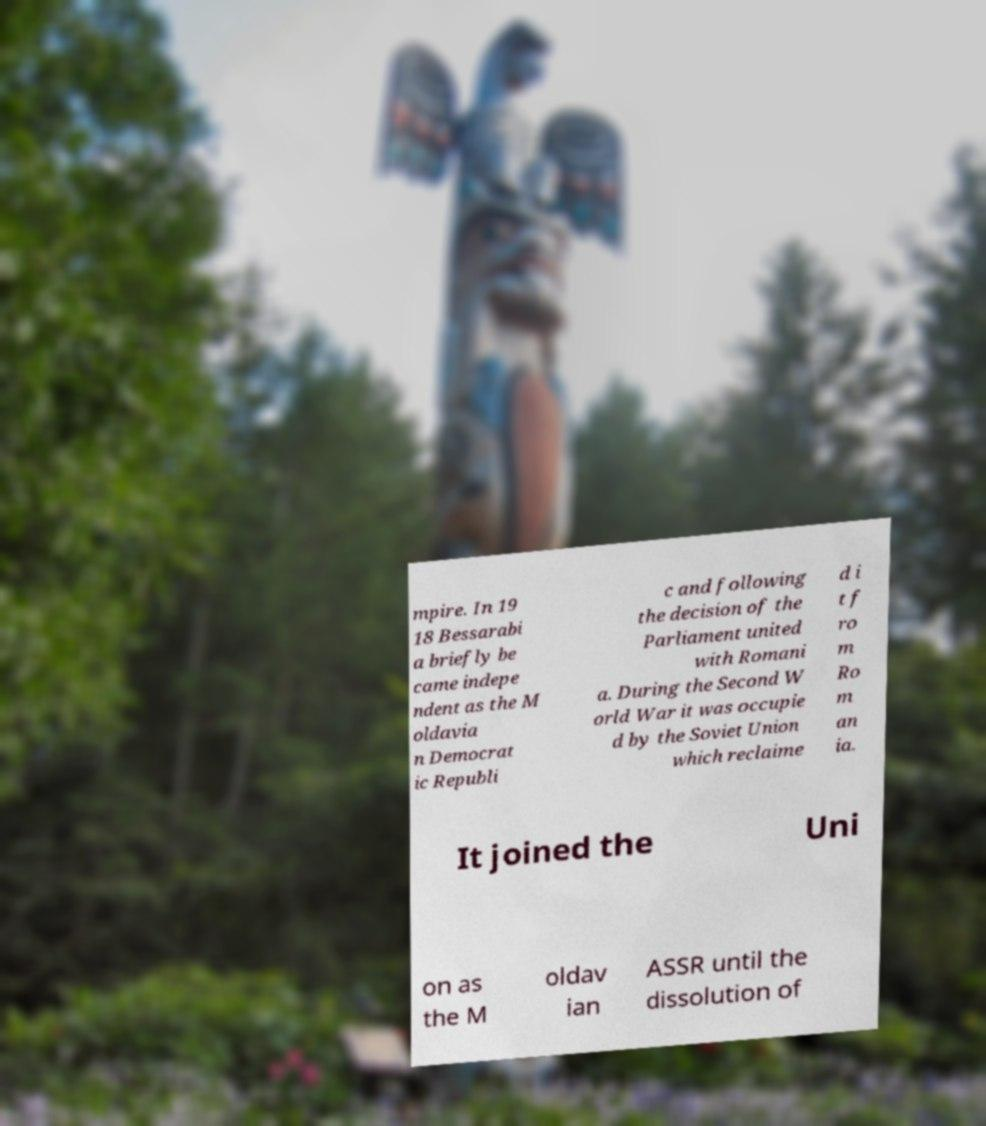What messages or text are displayed in this image? I need them in a readable, typed format. mpire. In 19 18 Bessarabi a briefly be came indepe ndent as the M oldavia n Democrat ic Republi c and following the decision of the Parliament united with Romani a. During the Second W orld War it was occupie d by the Soviet Union which reclaime d i t f ro m Ro m an ia. It joined the Uni on as the M oldav ian ASSR until the dissolution of 